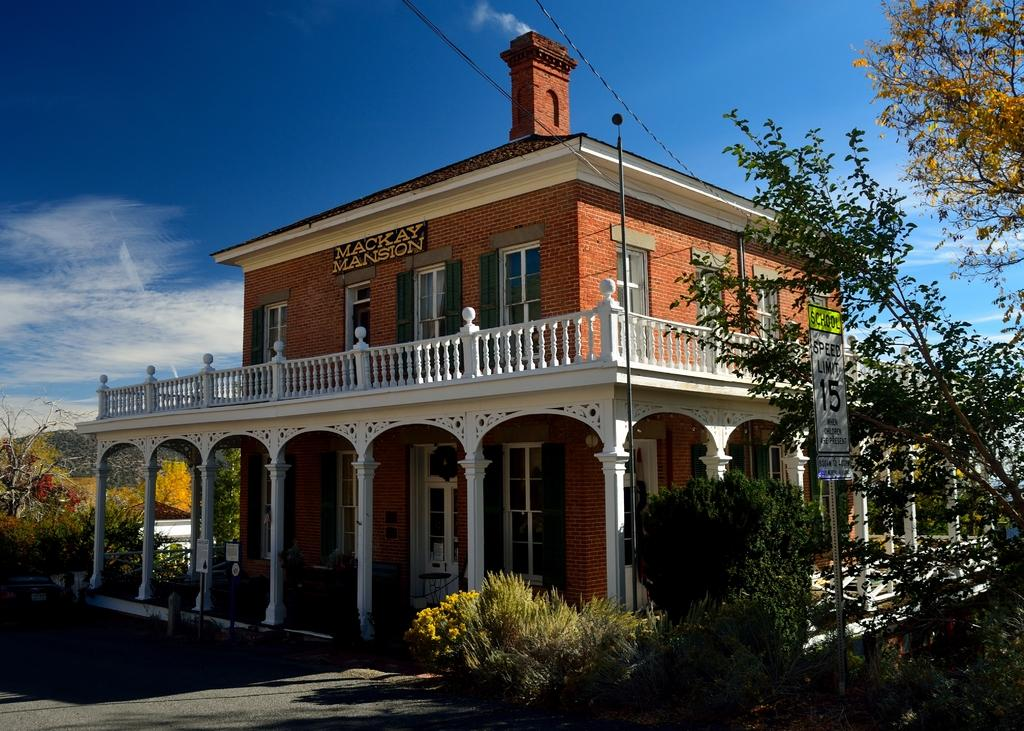What type of natural elements can be seen in the image? There are many trees in the image. What man-made object can be seen in the image? There is a board in the image. What type of structure is present in the image? There is a building with windows in the image. What safety feature is visible in the image? There is railing in the image. What can be seen in the background of the image? Clouds and the sky are visible in the background of the image. How many trucks are parked near the building in the image? There are no trucks present in the image. What type of exchange is taking place between the trees and the building in the image? There is no exchange between the trees and the building in the image; they are separate entities. 